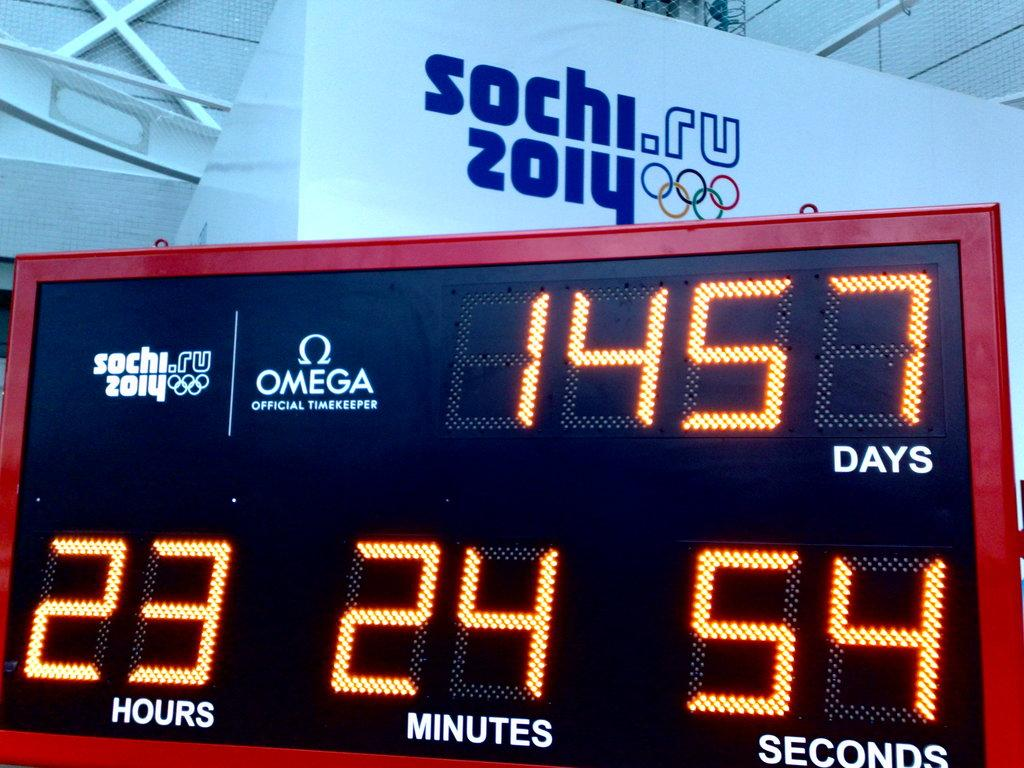Provide a one-sentence caption for the provided image. A timer counting days in relation to the 2014 Sochi Olympics. 